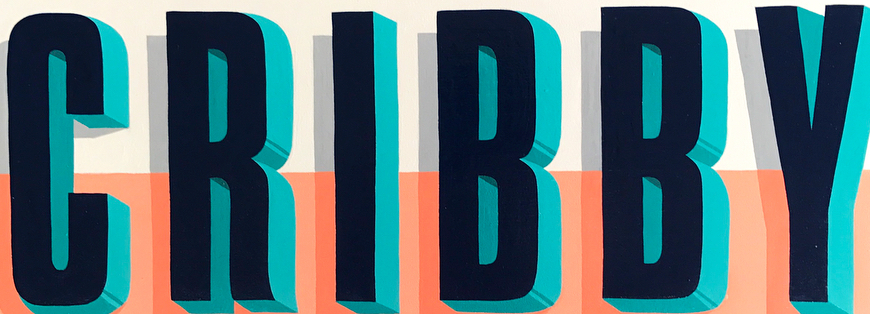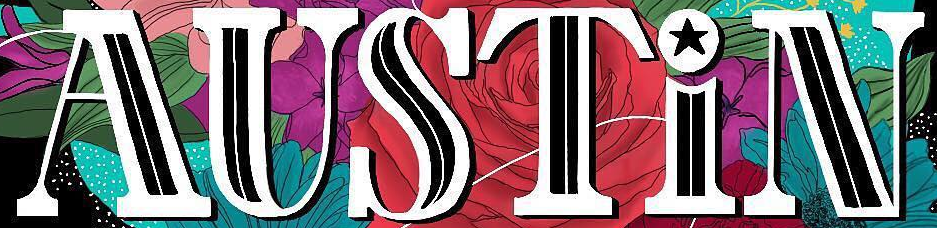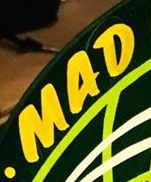What text appears in these images from left to right, separated by a semicolon? CRIBBY; AUSTiN; MAD 